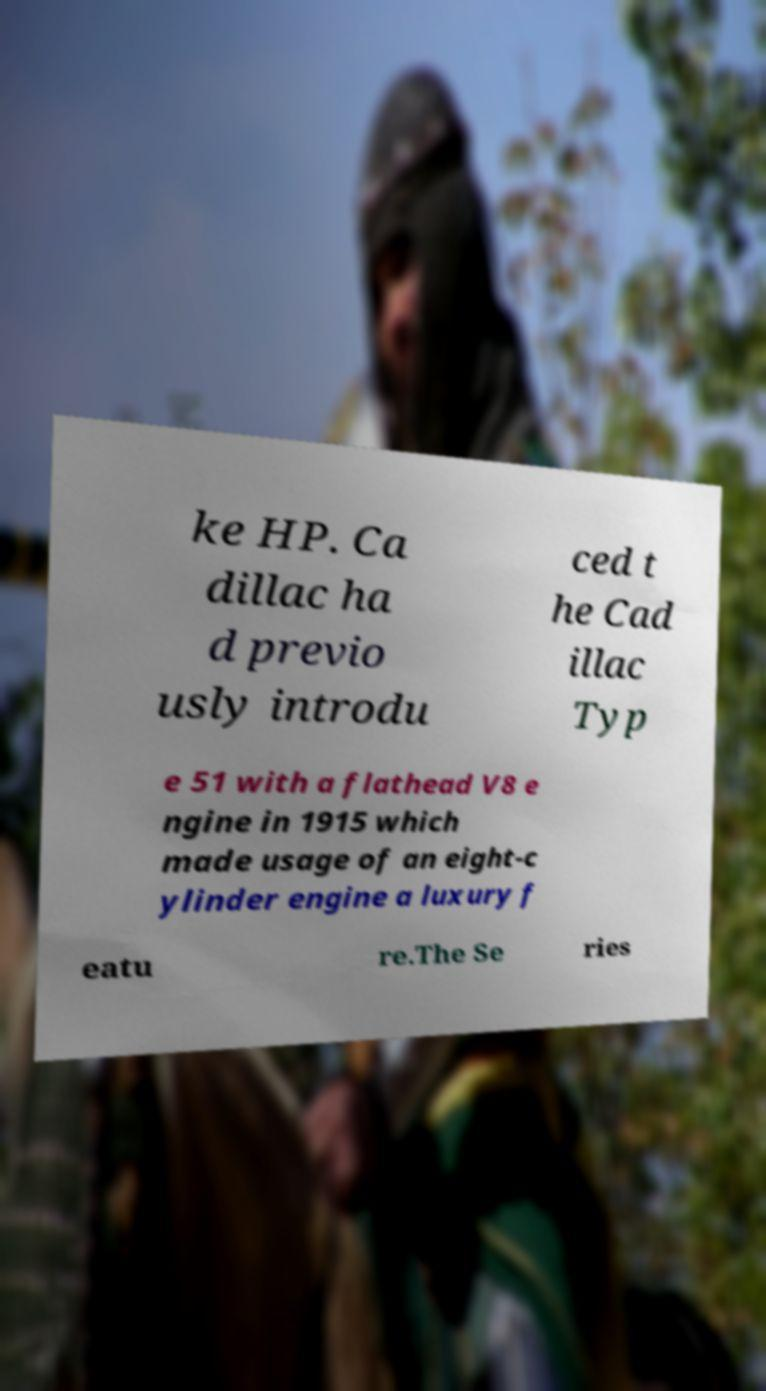Please identify and transcribe the text found in this image. ke HP. Ca dillac ha d previo usly introdu ced t he Cad illac Typ e 51 with a flathead V8 e ngine in 1915 which made usage of an eight-c ylinder engine a luxury f eatu re.The Se ries 